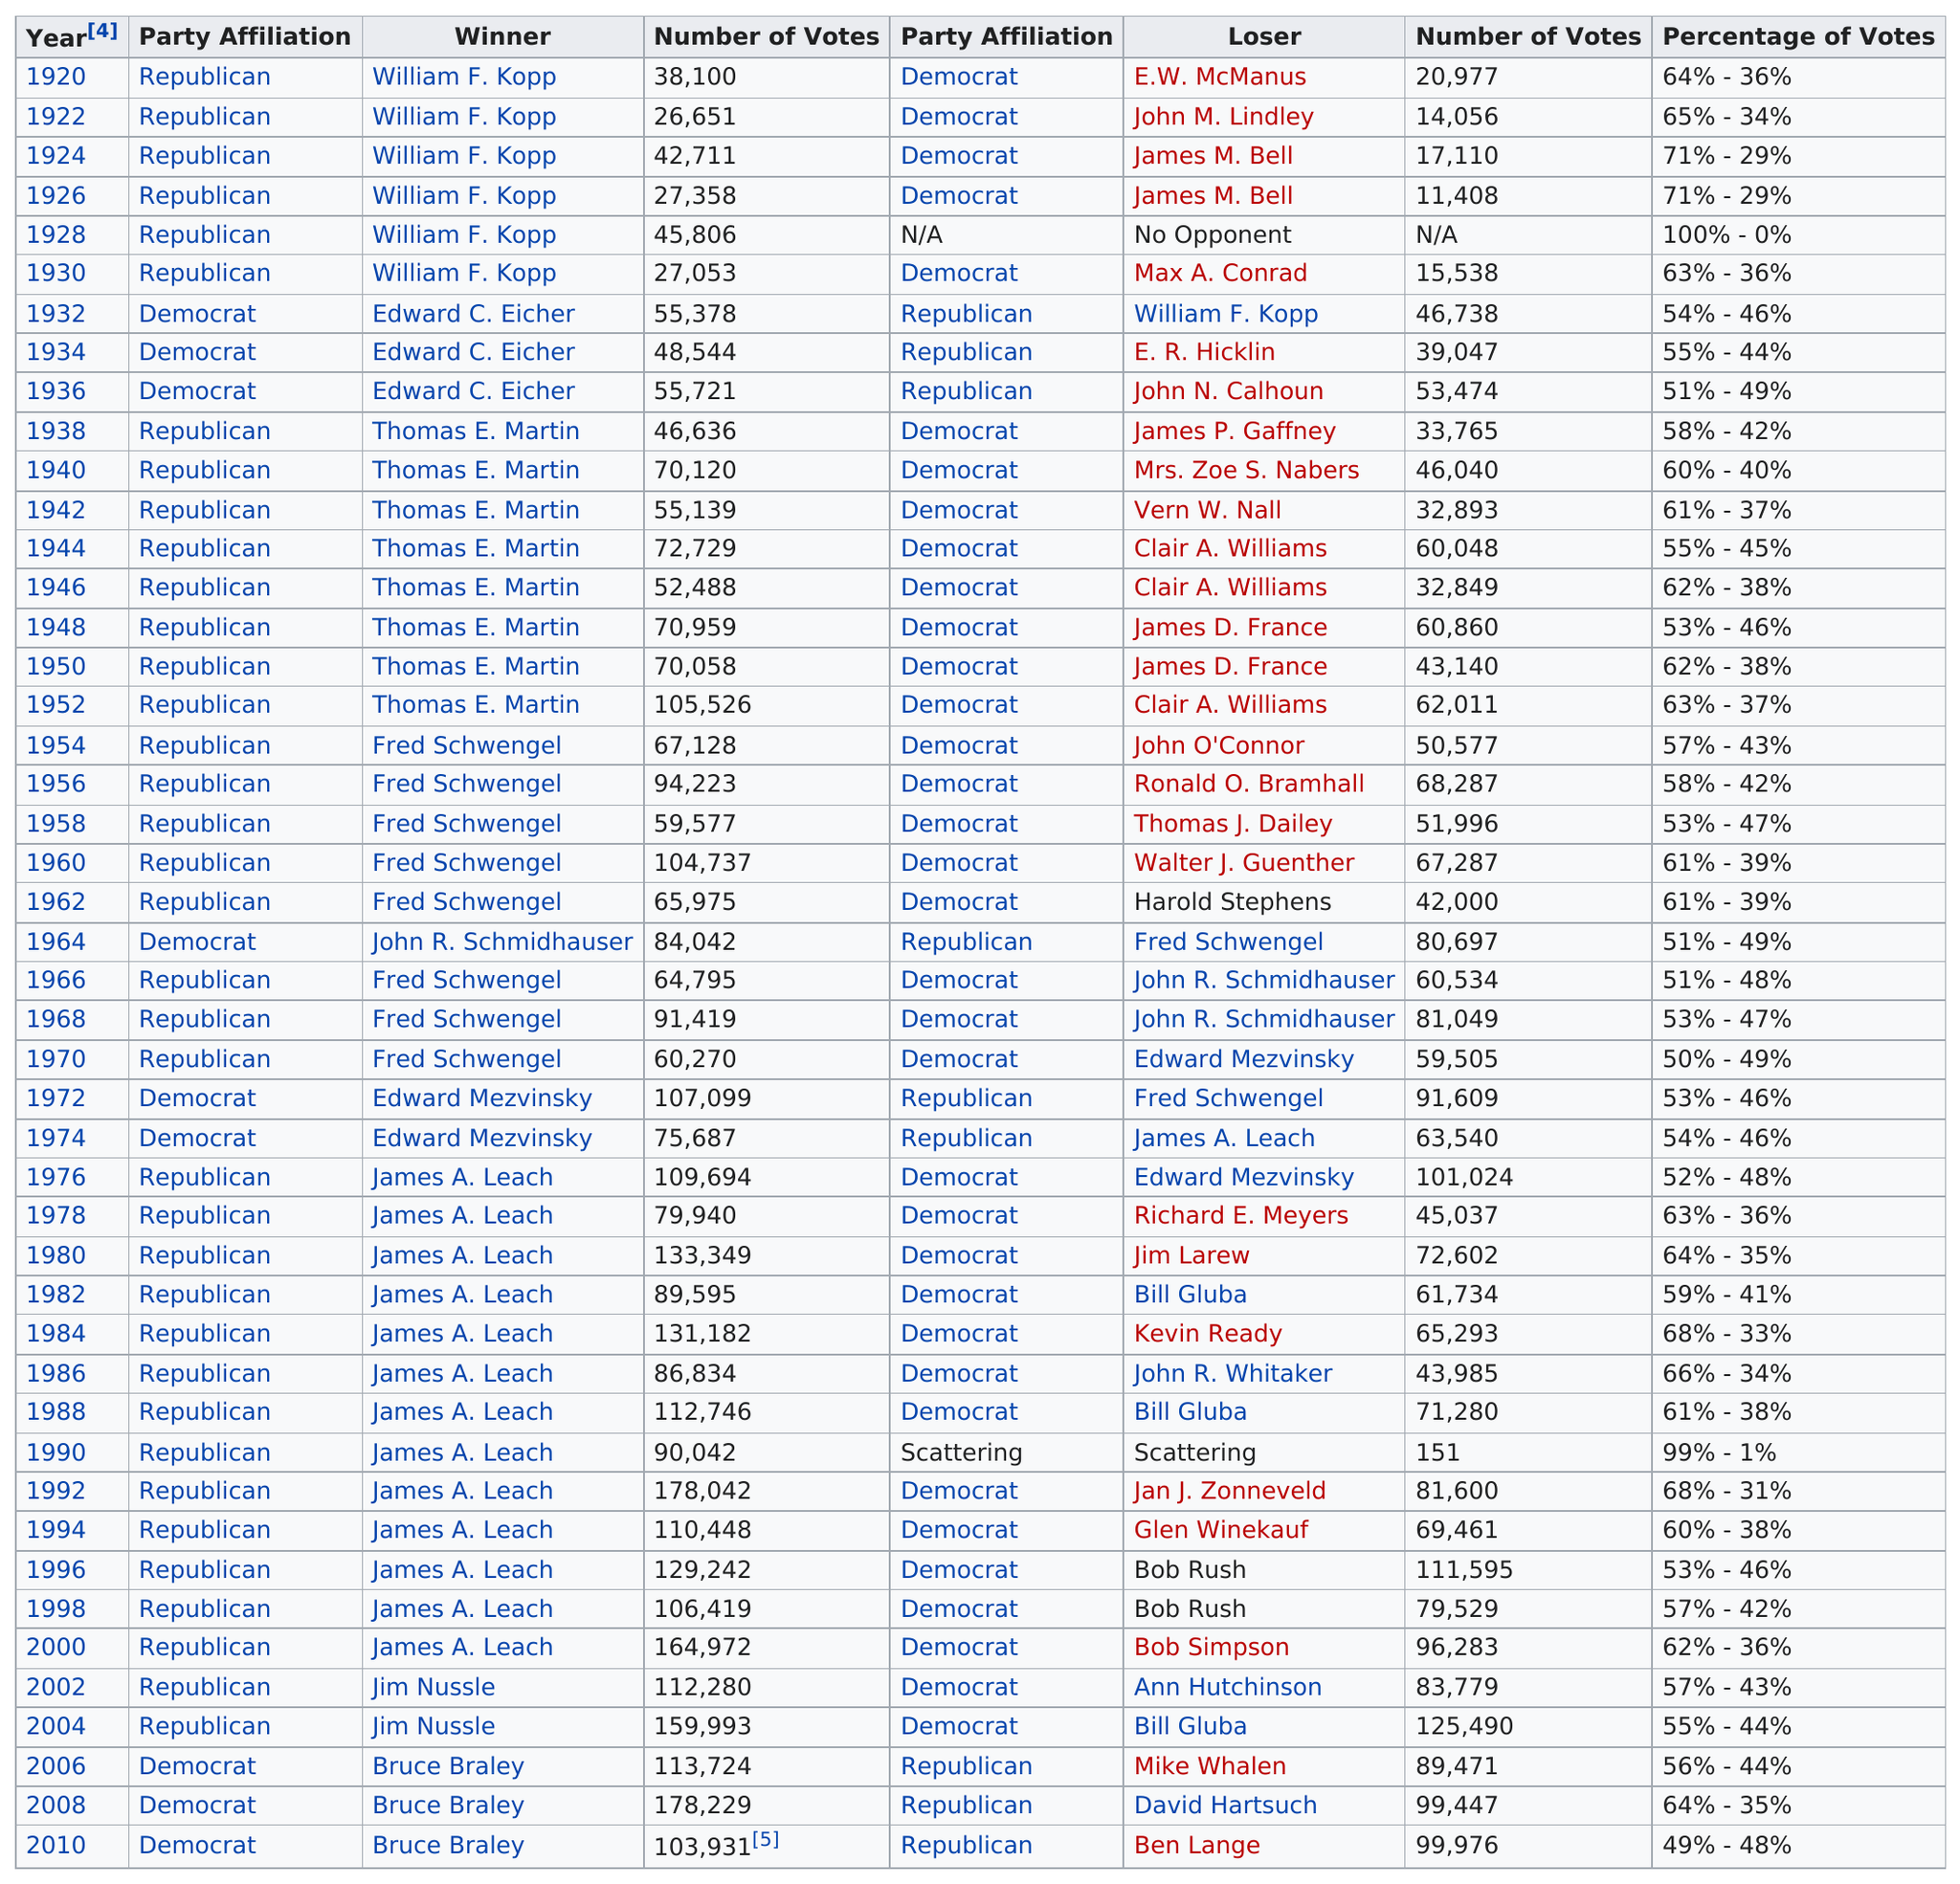Specify some key components in this picture. Jim Nussle was the last Republican to win. In the most recent election, there were 5 losing candidates who received at least 98,000 votes. William F. Kopp is the only winner who received 100% of the votes. William F. Kopp, the winner who received the least number of votes, won the competition. Thomas Martin held his seat for a total of 8 consecutive terms. 